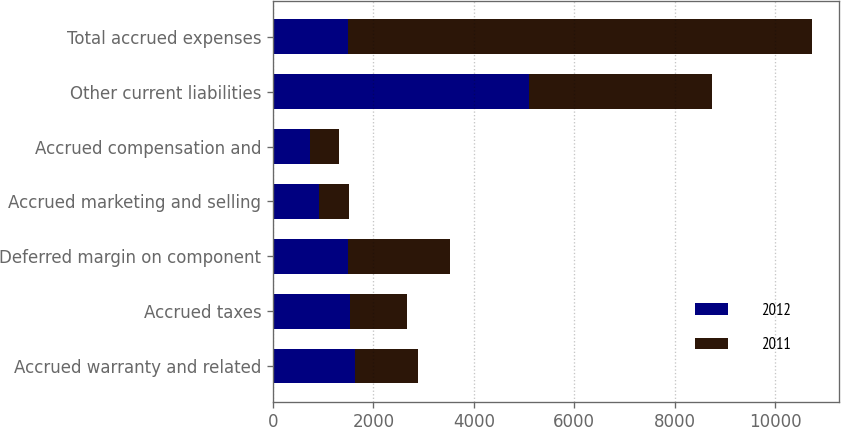Convert chart. <chart><loc_0><loc_0><loc_500><loc_500><stacked_bar_chart><ecel><fcel>Accrued warranty and related<fcel>Accrued taxes<fcel>Deferred margin on component<fcel>Accrued marketing and selling<fcel>Accrued compensation and<fcel>Other current liabilities<fcel>Total accrued expenses<nl><fcel>2012<fcel>1638<fcel>1535<fcel>1492<fcel>910<fcel>735<fcel>5104<fcel>1492<nl><fcel>2011<fcel>1240<fcel>1140<fcel>2038<fcel>598<fcel>590<fcel>3641<fcel>9247<nl></chart> 